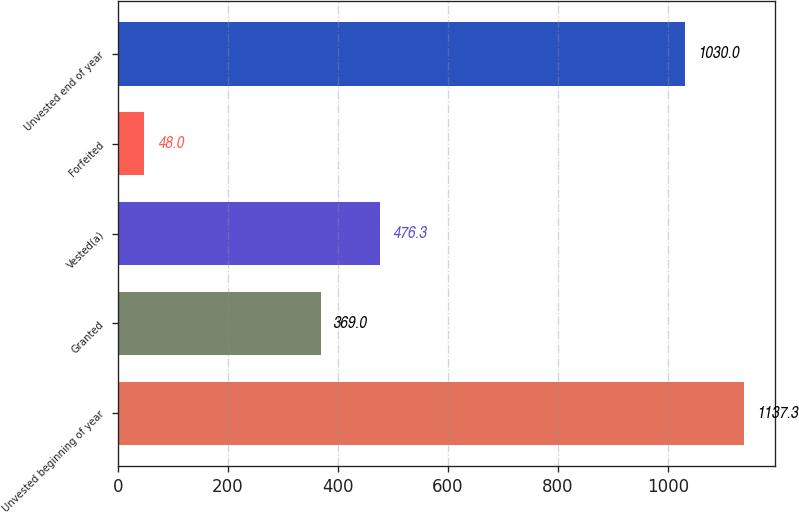Convert chart to OTSL. <chart><loc_0><loc_0><loc_500><loc_500><bar_chart><fcel>Unvested beginning of year<fcel>Granted<fcel>Vested(a)<fcel>Forfeited<fcel>Unvested end of year<nl><fcel>1137.3<fcel>369<fcel>476.3<fcel>48<fcel>1030<nl></chart> 